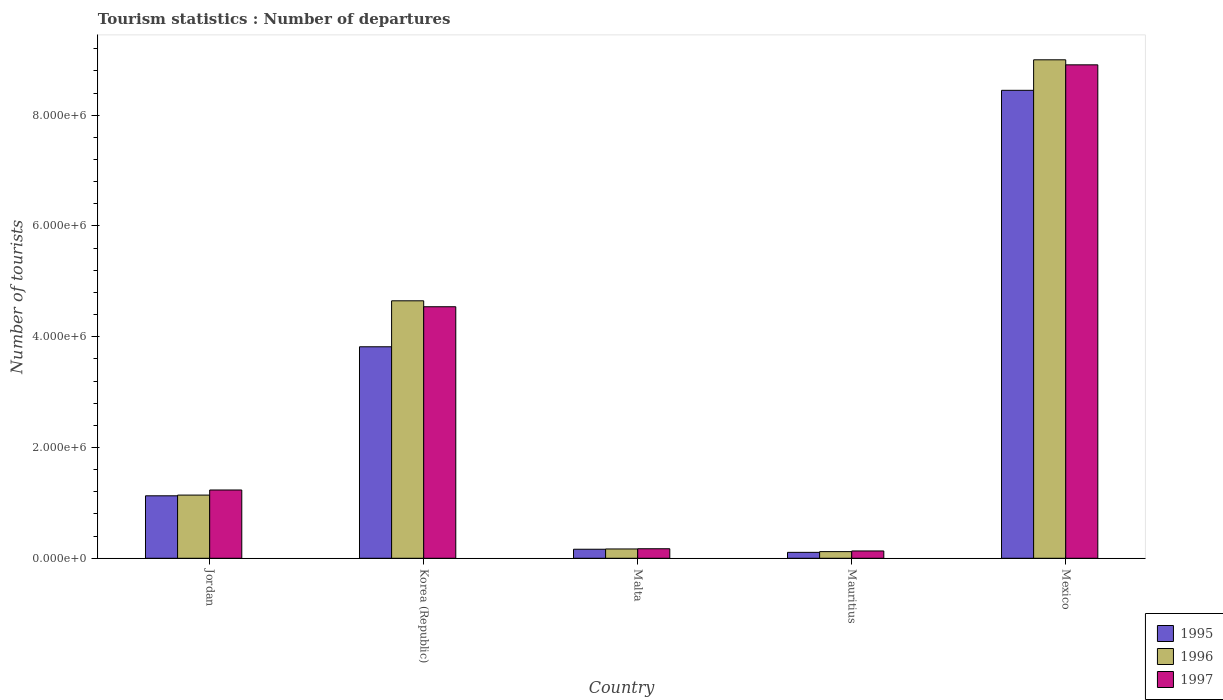How many different coloured bars are there?
Provide a short and direct response. 3. How many groups of bars are there?
Ensure brevity in your answer.  5. How many bars are there on the 1st tick from the left?
Give a very brief answer. 3. How many bars are there on the 1st tick from the right?
Provide a succinct answer. 3. What is the label of the 1st group of bars from the left?
Give a very brief answer. Jordan. In how many cases, is the number of bars for a given country not equal to the number of legend labels?
Keep it short and to the point. 0. What is the number of tourist departures in 1997 in Jordan?
Offer a very short reply. 1.23e+06. Across all countries, what is the maximum number of tourist departures in 1997?
Your answer should be very brief. 8.91e+06. Across all countries, what is the minimum number of tourist departures in 1997?
Offer a very short reply. 1.32e+05. In which country was the number of tourist departures in 1996 maximum?
Make the answer very short. Mexico. In which country was the number of tourist departures in 1995 minimum?
Give a very brief answer. Mauritius. What is the total number of tourist departures in 1995 in the graph?
Offer a terse response. 1.37e+07. What is the difference between the number of tourist departures in 1997 in Jordan and that in Korea (Republic)?
Your answer should be compact. -3.31e+06. What is the difference between the number of tourist departures in 1995 in Jordan and the number of tourist departures in 1997 in Korea (Republic)?
Give a very brief answer. -3.41e+06. What is the average number of tourist departures in 1995 per country?
Provide a short and direct response. 2.73e+06. What is the difference between the number of tourist departures of/in 1996 and number of tourist departures of/in 1995 in Mexico?
Ensure brevity in your answer.  5.51e+05. What is the ratio of the number of tourist departures in 1997 in Korea (Republic) to that in Mauritius?
Offer a terse response. 34.41. What is the difference between the highest and the second highest number of tourist departures in 1996?
Keep it short and to the point. 7.86e+06. What is the difference between the highest and the lowest number of tourist departures in 1997?
Provide a short and direct response. 8.78e+06. In how many countries, is the number of tourist departures in 1995 greater than the average number of tourist departures in 1995 taken over all countries?
Make the answer very short. 2. Is the sum of the number of tourist departures in 1996 in Korea (Republic) and Mauritius greater than the maximum number of tourist departures in 1997 across all countries?
Provide a short and direct response. No. Are all the bars in the graph horizontal?
Provide a succinct answer. No. How many countries are there in the graph?
Your answer should be very brief. 5. Are the values on the major ticks of Y-axis written in scientific E-notation?
Your answer should be compact. Yes. Does the graph contain any zero values?
Make the answer very short. No. Where does the legend appear in the graph?
Ensure brevity in your answer.  Bottom right. How are the legend labels stacked?
Provide a succinct answer. Vertical. What is the title of the graph?
Offer a very short reply. Tourism statistics : Number of departures. What is the label or title of the X-axis?
Your answer should be compact. Country. What is the label or title of the Y-axis?
Offer a very short reply. Number of tourists. What is the Number of tourists in 1995 in Jordan?
Make the answer very short. 1.13e+06. What is the Number of tourists in 1996 in Jordan?
Offer a terse response. 1.14e+06. What is the Number of tourists of 1997 in Jordan?
Offer a terse response. 1.23e+06. What is the Number of tourists in 1995 in Korea (Republic)?
Offer a terse response. 3.82e+06. What is the Number of tourists of 1996 in Korea (Republic)?
Offer a terse response. 4.65e+06. What is the Number of tourists of 1997 in Korea (Republic)?
Your response must be concise. 4.54e+06. What is the Number of tourists in 1995 in Malta?
Offer a very short reply. 1.63e+05. What is the Number of tourists in 1996 in Malta?
Offer a terse response. 1.68e+05. What is the Number of tourists in 1997 in Malta?
Your answer should be compact. 1.72e+05. What is the Number of tourists of 1995 in Mauritius?
Ensure brevity in your answer.  1.07e+05. What is the Number of tourists of 1996 in Mauritius?
Provide a short and direct response. 1.20e+05. What is the Number of tourists of 1997 in Mauritius?
Keep it short and to the point. 1.32e+05. What is the Number of tourists of 1995 in Mexico?
Ensure brevity in your answer.  8.45e+06. What is the Number of tourists of 1996 in Mexico?
Your response must be concise. 9.00e+06. What is the Number of tourists of 1997 in Mexico?
Offer a terse response. 8.91e+06. Across all countries, what is the maximum Number of tourists in 1995?
Provide a short and direct response. 8.45e+06. Across all countries, what is the maximum Number of tourists in 1996?
Your answer should be compact. 9.00e+06. Across all countries, what is the maximum Number of tourists of 1997?
Keep it short and to the point. 8.91e+06. Across all countries, what is the minimum Number of tourists of 1995?
Your answer should be compact. 1.07e+05. Across all countries, what is the minimum Number of tourists of 1997?
Ensure brevity in your answer.  1.32e+05. What is the total Number of tourists in 1995 in the graph?
Offer a terse response. 1.37e+07. What is the total Number of tourists of 1996 in the graph?
Your answer should be very brief. 1.51e+07. What is the total Number of tourists in 1997 in the graph?
Ensure brevity in your answer.  1.50e+07. What is the difference between the Number of tourists in 1995 in Jordan and that in Korea (Republic)?
Your answer should be very brief. -2.69e+06. What is the difference between the Number of tourists in 1996 in Jordan and that in Korea (Republic)?
Keep it short and to the point. -3.51e+06. What is the difference between the Number of tourists in 1997 in Jordan and that in Korea (Republic)?
Your answer should be very brief. -3.31e+06. What is the difference between the Number of tourists of 1995 in Jordan and that in Malta?
Ensure brevity in your answer.  9.65e+05. What is the difference between the Number of tourists in 1996 in Jordan and that in Malta?
Your answer should be very brief. 9.73e+05. What is the difference between the Number of tourists of 1997 in Jordan and that in Malta?
Offer a very short reply. 1.06e+06. What is the difference between the Number of tourists of 1995 in Jordan and that in Mauritius?
Give a very brief answer. 1.02e+06. What is the difference between the Number of tourists in 1996 in Jordan and that in Mauritius?
Ensure brevity in your answer.  1.02e+06. What is the difference between the Number of tourists of 1997 in Jordan and that in Mauritius?
Give a very brief answer. 1.10e+06. What is the difference between the Number of tourists of 1995 in Jordan and that in Mexico?
Make the answer very short. -7.32e+06. What is the difference between the Number of tourists in 1996 in Jordan and that in Mexico?
Offer a very short reply. -7.86e+06. What is the difference between the Number of tourists of 1997 in Jordan and that in Mexico?
Keep it short and to the point. -7.68e+06. What is the difference between the Number of tourists of 1995 in Korea (Republic) and that in Malta?
Your answer should be very brief. 3.66e+06. What is the difference between the Number of tourists in 1996 in Korea (Republic) and that in Malta?
Make the answer very short. 4.48e+06. What is the difference between the Number of tourists of 1997 in Korea (Republic) and that in Malta?
Make the answer very short. 4.37e+06. What is the difference between the Number of tourists of 1995 in Korea (Republic) and that in Mauritius?
Your response must be concise. 3.71e+06. What is the difference between the Number of tourists of 1996 in Korea (Republic) and that in Mauritius?
Provide a succinct answer. 4.53e+06. What is the difference between the Number of tourists in 1997 in Korea (Republic) and that in Mauritius?
Offer a very short reply. 4.41e+06. What is the difference between the Number of tourists of 1995 in Korea (Republic) and that in Mexico?
Give a very brief answer. -4.63e+06. What is the difference between the Number of tourists in 1996 in Korea (Republic) and that in Mexico?
Provide a short and direct response. -4.35e+06. What is the difference between the Number of tourists in 1997 in Korea (Republic) and that in Mexico?
Your answer should be compact. -4.37e+06. What is the difference between the Number of tourists in 1995 in Malta and that in Mauritius?
Your answer should be very brief. 5.60e+04. What is the difference between the Number of tourists of 1996 in Malta and that in Mauritius?
Make the answer very short. 4.80e+04. What is the difference between the Number of tourists in 1995 in Malta and that in Mexico?
Offer a terse response. -8.29e+06. What is the difference between the Number of tourists in 1996 in Malta and that in Mexico?
Provide a succinct answer. -8.83e+06. What is the difference between the Number of tourists of 1997 in Malta and that in Mexico?
Give a very brief answer. -8.74e+06. What is the difference between the Number of tourists of 1995 in Mauritius and that in Mexico?
Ensure brevity in your answer.  -8.34e+06. What is the difference between the Number of tourists of 1996 in Mauritius and that in Mexico?
Provide a short and direct response. -8.88e+06. What is the difference between the Number of tourists of 1997 in Mauritius and that in Mexico?
Your response must be concise. -8.78e+06. What is the difference between the Number of tourists of 1995 in Jordan and the Number of tourists of 1996 in Korea (Republic)?
Your response must be concise. -3.52e+06. What is the difference between the Number of tourists in 1995 in Jordan and the Number of tourists in 1997 in Korea (Republic)?
Your answer should be compact. -3.41e+06. What is the difference between the Number of tourists in 1996 in Jordan and the Number of tourists in 1997 in Korea (Republic)?
Make the answer very short. -3.40e+06. What is the difference between the Number of tourists of 1995 in Jordan and the Number of tourists of 1996 in Malta?
Provide a short and direct response. 9.60e+05. What is the difference between the Number of tourists of 1995 in Jordan and the Number of tourists of 1997 in Malta?
Give a very brief answer. 9.56e+05. What is the difference between the Number of tourists in 1996 in Jordan and the Number of tourists in 1997 in Malta?
Offer a very short reply. 9.69e+05. What is the difference between the Number of tourists in 1995 in Jordan and the Number of tourists in 1996 in Mauritius?
Offer a very short reply. 1.01e+06. What is the difference between the Number of tourists of 1995 in Jordan and the Number of tourists of 1997 in Mauritius?
Keep it short and to the point. 9.96e+05. What is the difference between the Number of tourists in 1996 in Jordan and the Number of tourists in 1997 in Mauritius?
Your response must be concise. 1.01e+06. What is the difference between the Number of tourists of 1995 in Jordan and the Number of tourists of 1996 in Mexico?
Your answer should be compact. -7.87e+06. What is the difference between the Number of tourists of 1995 in Jordan and the Number of tourists of 1997 in Mexico?
Offer a very short reply. -7.78e+06. What is the difference between the Number of tourists of 1996 in Jordan and the Number of tourists of 1997 in Mexico?
Your response must be concise. -7.77e+06. What is the difference between the Number of tourists of 1995 in Korea (Republic) and the Number of tourists of 1996 in Malta?
Your response must be concise. 3.65e+06. What is the difference between the Number of tourists of 1995 in Korea (Republic) and the Number of tourists of 1997 in Malta?
Offer a very short reply. 3.65e+06. What is the difference between the Number of tourists of 1996 in Korea (Republic) and the Number of tourists of 1997 in Malta?
Give a very brief answer. 4.48e+06. What is the difference between the Number of tourists in 1995 in Korea (Republic) and the Number of tourists in 1996 in Mauritius?
Your response must be concise. 3.70e+06. What is the difference between the Number of tourists in 1995 in Korea (Republic) and the Number of tourists in 1997 in Mauritius?
Your response must be concise. 3.69e+06. What is the difference between the Number of tourists in 1996 in Korea (Republic) and the Number of tourists in 1997 in Mauritius?
Give a very brief answer. 4.52e+06. What is the difference between the Number of tourists of 1995 in Korea (Republic) and the Number of tourists of 1996 in Mexico?
Give a very brief answer. -5.18e+06. What is the difference between the Number of tourists of 1995 in Korea (Republic) and the Number of tourists of 1997 in Mexico?
Offer a terse response. -5.09e+06. What is the difference between the Number of tourists in 1996 in Korea (Republic) and the Number of tourists in 1997 in Mexico?
Keep it short and to the point. -4.26e+06. What is the difference between the Number of tourists in 1995 in Malta and the Number of tourists in 1996 in Mauritius?
Provide a succinct answer. 4.30e+04. What is the difference between the Number of tourists of 1995 in Malta and the Number of tourists of 1997 in Mauritius?
Offer a terse response. 3.10e+04. What is the difference between the Number of tourists in 1996 in Malta and the Number of tourists in 1997 in Mauritius?
Your answer should be very brief. 3.60e+04. What is the difference between the Number of tourists in 1995 in Malta and the Number of tourists in 1996 in Mexico?
Give a very brief answer. -8.84e+06. What is the difference between the Number of tourists in 1995 in Malta and the Number of tourists in 1997 in Mexico?
Provide a succinct answer. -8.75e+06. What is the difference between the Number of tourists in 1996 in Malta and the Number of tourists in 1997 in Mexico?
Provide a succinct answer. -8.74e+06. What is the difference between the Number of tourists in 1995 in Mauritius and the Number of tourists in 1996 in Mexico?
Give a very brief answer. -8.89e+06. What is the difference between the Number of tourists of 1995 in Mauritius and the Number of tourists of 1997 in Mexico?
Ensure brevity in your answer.  -8.80e+06. What is the difference between the Number of tourists in 1996 in Mauritius and the Number of tourists in 1997 in Mexico?
Provide a short and direct response. -8.79e+06. What is the average Number of tourists of 1995 per country?
Offer a terse response. 2.73e+06. What is the average Number of tourists of 1996 per country?
Your response must be concise. 3.02e+06. What is the average Number of tourists in 1997 per country?
Ensure brevity in your answer.  3.00e+06. What is the difference between the Number of tourists in 1995 and Number of tourists in 1996 in Jordan?
Give a very brief answer. -1.30e+04. What is the difference between the Number of tourists of 1995 and Number of tourists of 1997 in Jordan?
Make the answer very short. -1.05e+05. What is the difference between the Number of tourists of 1996 and Number of tourists of 1997 in Jordan?
Ensure brevity in your answer.  -9.20e+04. What is the difference between the Number of tourists of 1995 and Number of tourists of 1996 in Korea (Republic)?
Provide a succinct answer. -8.30e+05. What is the difference between the Number of tourists in 1995 and Number of tourists in 1997 in Korea (Republic)?
Keep it short and to the point. -7.23e+05. What is the difference between the Number of tourists in 1996 and Number of tourists in 1997 in Korea (Republic)?
Offer a terse response. 1.07e+05. What is the difference between the Number of tourists in 1995 and Number of tourists in 1996 in Malta?
Ensure brevity in your answer.  -5000. What is the difference between the Number of tourists in 1995 and Number of tourists in 1997 in Malta?
Offer a very short reply. -9000. What is the difference between the Number of tourists of 1996 and Number of tourists of 1997 in Malta?
Ensure brevity in your answer.  -4000. What is the difference between the Number of tourists of 1995 and Number of tourists of 1996 in Mauritius?
Your answer should be very brief. -1.30e+04. What is the difference between the Number of tourists of 1995 and Number of tourists of 1997 in Mauritius?
Offer a terse response. -2.50e+04. What is the difference between the Number of tourists in 1996 and Number of tourists in 1997 in Mauritius?
Give a very brief answer. -1.20e+04. What is the difference between the Number of tourists in 1995 and Number of tourists in 1996 in Mexico?
Ensure brevity in your answer.  -5.51e+05. What is the difference between the Number of tourists of 1995 and Number of tourists of 1997 in Mexico?
Make the answer very short. -4.60e+05. What is the difference between the Number of tourists in 1996 and Number of tourists in 1997 in Mexico?
Keep it short and to the point. 9.10e+04. What is the ratio of the Number of tourists in 1995 in Jordan to that in Korea (Republic)?
Keep it short and to the point. 0.3. What is the ratio of the Number of tourists of 1996 in Jordan to that in Korea (Republic)?
Give a very brief answer. 0.25. What is the ratio of the Number of tourists of 1997 in Jordan to that in Korea (Republic)?
Give a very brief answer. 0.27. What is the ratio of the Number of tourists of 1995 in Jordan to that in Malta?
Your answer should be compact. 6.92. What is the ratio of the Number of tourists of 1996 in Jordan to that in Malta?
Offer a terse response. 6.79. What is the ratio of the Number of tourists in 1997 in Jordan to that in Malta?
Give a very brief answer. 7.17. What is the ratio of the Number of tourists in 1995 in Jordan to that in Mauritius?
Your response must be concise. 10.54. What is the ratio of the Number of tourists of 1996 in Jordan to that in Mauritius?
Provide a short and direct response. 9.51. What is the ratio of the Number of tourists in 1997 in Jordan to that in Mauritius?
Ensure brevity in your answer.  9.34. What is the ratio of the Number of tourists of 1995 in Jordan to that in Mexico?
Make the answer very short. 0.13. What is the ratio of the Number of tourists of 1996 in Jordan to that in Mexico?
Provide a succinct answer. 0.13. What is the ratio of the Number of tourists of 1997 in Jordan to that in Mexico?
Offer a terse response. 0.14. What is the ratio of the Number of tourists in 1995 in Korea (Republic) to that in Malta?
Provide a succinct answer. 23.43. What is the ratio of the Number of tourists of 1996 in Korea (Republic) to that in Malta?
Offer a terse response. 27.67. What is the ratio of the Number of tourists of 1997 in Korea (Republic) to that in Malta?
Keep it short and to the point. 26.41. What is the ratio of the Number of tourists of 1995 in Korea (Republic) to that in Mauritius?
Your answer should be very brief. 35.69. What is the ratio of the Number of tourists in 1996 in Korea (Republic) to that in Mauritius?
Provide a succinct answer. 38.74. What is the ratio of the Number of tourists in 1997 in Korea (Republic) to that in Mauritius?
Offer a very short reply. 34.41. What is the ratio of the Number of tourists of 1995 in Korea (Republic) to that in Mexico?
Keep it short and to the point. 0.45. What is the ratio of the Number of tourists in 1996 in Korea (Republic) to that in Mexico?
Provide a short and direct response. 0.52. What is the ratio of the Number of tourists of 1997 in Korea (Republic) to that in Mexico?
Provide a short and direct response. 0.51. What is the ratio of the Number of tourists in 1995 in Malta to that in Mauritius?
Offer a terse response. 1.52. What is the ratio of the Number of tourists in 1997 in Malta to that in Mauritius?
Offer a very short reply. 1.3. What is the ratio of the Number of tourists of 1995 in Malta to that in Mexico?
Give a very brief answer. 0.02. What is the ratio of the Number of tourists of 1996 in Malta to that in Mexico?
Your answer should be compact. 0.02. What is the ratio of the Number of tourists of 1997 in Malta to that in Mexico?
Offer a terse response. 0.02. What is the ratio of the Number of tourists of 1995 in Mauritius to that in Mexico?
Provide a short and direct response. 0.01. What is the ratio of the Number of tourists of 1996 in Mauritius to that in Mexico?
Provide a succinct answer. 0.01. What is the ratio of the Number of tourists of 1997 in Mauritius to that in Mexico?
Offer a very short reply. 0.01. What is the difference between the highest and the second highest Number of tourists of 1995?
Give a very brief answer. 4.63e+06. What is the difference between the highest and the second highest Number of tourists of 1996?
Give a very brief answer. 4.35e+06. What is the difference between the highest and the second highest Number of tourists in 1997?
Your answer should be very brief. 4.37e+06. What is the difference between the highest and the lowest Number of tourists of 1995?
Your answer should be compact. 8.34e+06. What is the difference between the highest and the lowest Number of tourists in 1996?
Your response must be concise. 8.88e+06. What is the difference between the highest and the lowest Number of tourists in 1997?
Your answer should be very brief. 8.78e+06. 